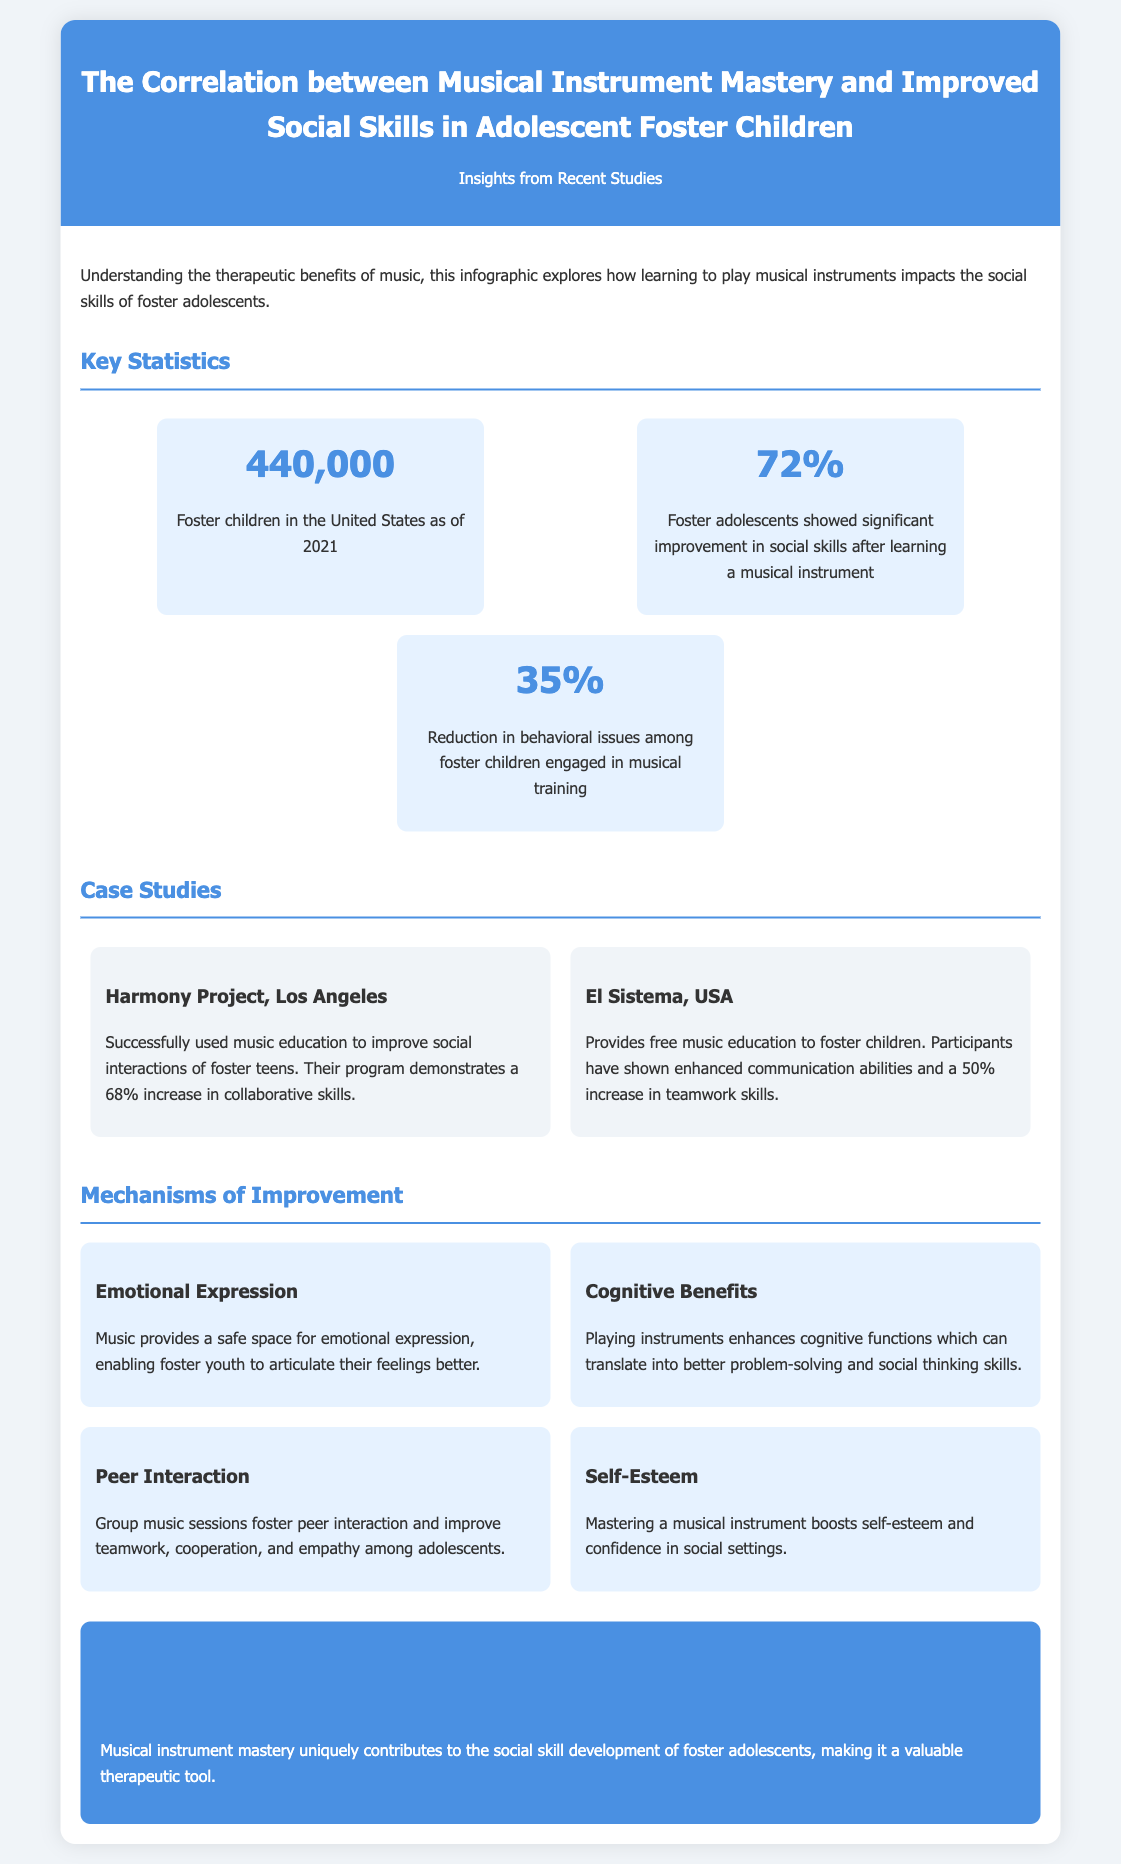What is the total number of foster children in the United States as of 2021? The document states that there are 440,000 foster children in the United States as of 2021.
Answer: 440,000 What percentage of foster adolescents showed improvement in social skills? According to the infographic, 72% of foster adolescents showed significant improvement in social skills after learning a musical instrument.
Answer: 72% What was the reduction percentage in behavioral issues among foster children engaged in musical training? The document mentions a 35% reduction in behavioral issues among foster children who participated in musical training.
Answer: 35% Which program in Los Angeles reported a 68% increase in collaborative skills? The Harmony Project in Los Angeles is noted for successfully using music education to improve social interactions of foster teens and reported a 68% increase in collaborative skills.
Answer: Harmony Project What emotional mechanism does music provide for foster youth? The infographic states that music provides a safe space for emotional expression, helping foster youth articulate their feelings better.
Answer: Emotional Expression How many mechanisms of improvement are identified in the document? The document outlines four mechanisms of improvement related to social skills development through music.
Answer: Four Which program provides free music education in the USA? El Sistema is the program mentioned that provides free music education to foster children in the USA.
Answer: El Sistema What is the conclusion regarding musical instrument mastery for foster adolescents? The conclusion states that musical instrument mastery contributes uniquely to the social skill development of foster adolescents, making it a valuable therapeutic tool.
Answer: Valuable therapeutic tool 